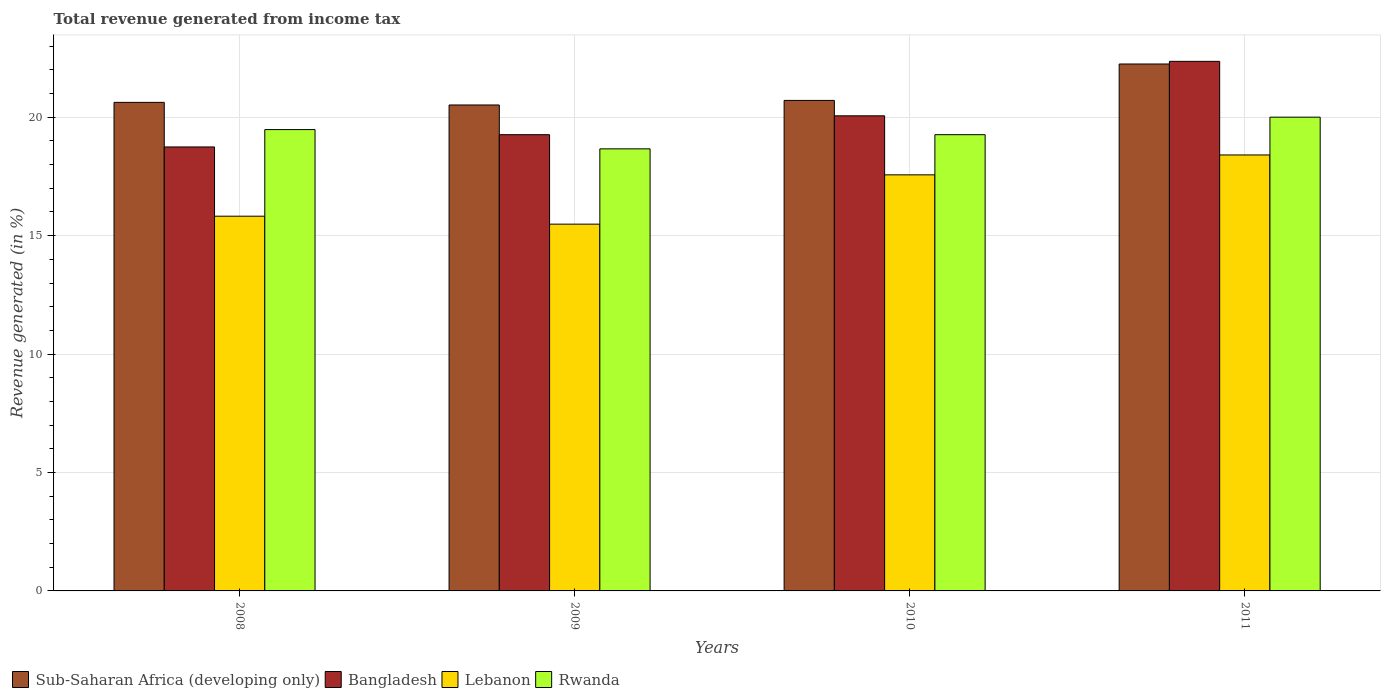How many different coloured bars are there?
Offer a terse response. 4. How many groups of bars are there?
Your answer should be very brief. 4. Are the number of bars per tick equal to the number of legend labels?
Make the answer very short. Yes. Are the number of bars on each tick of the X-axis equal?
Keep it short and to the point. Yes. What is the label of the 3rd group of bars from the left?
Provide a short and direct response. 2010. What is the total revenue generated in Lebanon in 2009?
Your response must be concise. 15.49. Across all years, what is the maximum total revenue generated in Rwanda?
Ensure brevity in your answer.  20. Across all years, what is the minimum total revenue generated in Bangladesh?
Give a very brief answer. 18.74. In which year was the total revenue generated in Rwanda maximum?
Keep it short and to the point. 2011. What is the total total revenue generated in Sub-Saharan Africa (developing only) in the graph?
Ensure brevity in your answer.  84.1. What is the difference between the total revenue generated in Rwanda in 2010 and that in 2011?
Your answer should be compact. -0.74. What is the difference between the total revenue generated in Bangladesh in 2008 and the total revenue generated in Sub-Saharan Africa (developing only) in 2009?
Keep it short and to the point. -1.77. What is the average total revenue generated in Rwanda per year?
Keep it short and to the point. 19.35. In the year 2008, what is the difference between the total revenue generated in Sub-Saharan Africa (developing only) and total revenue generated in Bangladesh?
Provide a succinct answer. 1.88. What is the ratio of the total revenue generated in Lebanon in 2009 to that in 2011?
Your answer should be compact. 0.84. Is the difference between the total revenue generated in Sub-Saharan Africa (developing only) in 2008 and 2009 greater than the difference between the total revenue generated in Bangladesh in 2008 and 2009?
Offer a terse response. Yes. What is the difference between the highest and the second highest total revenue generated in Rwanda?
Make the answer very short. 0.52. What is the difference between the highest and the lowest total revenue generated in Bangladesh?
Provide a succinct answer. 3.61. In how many years, is the total revenue generated in Bangladesh greater than the average total revenue generated in Bangladesh taken over all years?
Give a very brief answer. 1. Is the sum of the total revenue generated in Bangladesh in 2008 and 2011 greater than the maximum total revenue generated in Sub-Saharan Africa (developing only) across all years?
Provide a short and direct response. Yes. Is it the case that in every year, the sum of the total revenue generated in Rwanda and total revenue generated in Sub-Saharan Africa (developing only) is greater than the sum of total revenue generated in Bangladesh and total revenue generated in Lebanon?
Provide a succinct answer. Yes. What does the 1st bar from the left in 2010 represents?
Your answer should be very brief. Sub-Saharan Africa (developing only). What does the 4th bar from the right in 2008 represents?
Ensure brevity in your answer.  Sub-Saharan Africa (developing only). Is it the case that in every year, the sum of the total revenue generated in Bangladesh and total revenue generated in Lebanon is greater than the total revenue generated in Rwanda?
Provide a succinct answer. Yes. How many bars are there?
Your answer should be compact. 16. How many years are there in the graph?
Provide a short and direct response. 4. Where does the legend appear in the graph?
Make the answer very short. Bottom left. How are the legend labels stacked?
Provide a succinct answer. Horizontal. What is the title of the graph?
Your answer should be very brief. Total revenue generated from income tax. What is the label or title of the X-axis?
Offer a very short reply. Years. What is the label or title of the Y-axis?
Your response must be concise. Revenue generated (in %). What is the Revenue generated (in %) of Sub-Saharan Africa (developing only) in 2008?
Keep it short and to the point. 20.63. What is the Revenue generated (in %) in Bangladesh in 2008?
Your response must be concise. 18.74. What is the Revenue generated (in %) of Lebanon in 2008?
Provide a short and direct response. 15.82. What is the Revenue generated (in %) of Rwanda in 2008?
Provide a succinct answer. 19.48. What is the Revenue generated (in %) of Sub-Saharan Africa (developing only) in 2009?
Keep it short and to the point. 20.52. What is the Revenue generated (in %) in Bangladesh in 2009?
Your answer should be very brief. 19.26. What is the Revenue generated (in %) in Lebanon in 2009?
Keep it short and to the point. 15.49. What is the Revenue generated (in %) of Rwanda in 2009?
Provide a succinct answer. 18.66. What is the Revenue generated (in %) of Sub-Saharan Africa (developing only) in 2010?
Your response must be concise. 20.71. What is the Revenue generated (in %) of Bangladesh in 2010?
Your answer should be very brief. 20.06. What is the Revenue generated (in %) in Lebanon in 2010?
Give a very brief answer. 17.57. What is the Revenue generated (in %) in Rwanda in 2010?
Offer a very short reply. 19.26. What is the Revenue generated (in %) in Sub-Saharan Africa (developing only) in 2011?
Your answer should be compact. 22.25. What is the Revenue generated (in %) of Bangladesh in 2011?
Provide a short and direct response. 22.36. What is the Revenue generated (in %) in Lebanon in 2011?
Give a very brief answer. 18.41. What is the Revenue generated (in %) of Rwanda in 2011?
Your answer should be compact. 20. Across all years, what is the maximum Revenue generated (in %) in Sub-Saharan Africa (developing only)?
Your response must be concise. 22.25. Across all years, what is the maximum Revenue generated (in %) of Bangladesh?
Keep it short and to the point. 22.36. Across all years, what is the maximum Revenue generated (in %) in Lebanon?
Give a very brief answer. 18.41. Across all years, what is the maximum Revenue generated (in %) in Rwanda?
Make the answer very short. 20. Across all years, what is the minimum Revenue generated (in %) in Sub-Saharan Africa (developing only)?
Your answer should be compact. 20.52. Across all years, what is the minimum Revenue generated (in %) in Bangladesh?
Your answer should be compact. 18.74. Across all years, what is the minimum Revenue generated (in %) of Lebanon?
Your answer should be very brief. 15.49. Across all years, what is the minimum Revenue generated (in %) in Rwanda?
Ensure brevity in your answer.  18.66. What is the total Revenue generated (in %) of Sub-Saharan Africa (developing only) in the graph?
Keep it short and to the point. 84.1. What is the total Revenue generated (in %) in Bangladesh in the graph?
Offer a terse response. 80.42. What is the total Revenue generated (in %) in Lebanon in the graph?
Keep it short and to the point. 67.28. What is the total Revenue generated (in %) in Rwanda in the graph?
Keep it short and to the point. 77.41. What is the difference between the Revenue generated (in %) of Sub-Saharan Africa (developing only) in 2008 and that in 2009?
Your answer should be compact. 0.11. What is the difference between the Revenue generated (in %) of Bangladesh in 2008 and that in 2009?
Provide a succinct answer. -0.52. What is the difference between the Revenue generated (in %) in Lebanon in 2008 and that in 2009?
Your answer should be compact. 0.34. What is the difference between the Revenue generated (in %) in Rwanda in 2008 and that in 2009?
Your response must be concise. 0.81. What is the difference between the Revenue generated (in %) of Sub-Saharan Africa (developing only) in 2008 and that in 2010?
Ensure brevity in your answer.  -0.08. What is the difference between the Revenue generated (in %) of Bangladesh in 2008 and that in 2010?
Your response must be concise. -1.31. What is the difference between the Revenue generated (in %) in Lebanon in 2008 and that in 2010?
Provide a succinct answer. -1.75. What is the difference between the Revenue generated (in %) in Rwanda in 2008 and that in 2010?
Offer a terse response. 0.22. What is the difference between the Revenue generated (in %) in Sub-Saharan Africa (developing only) in 2008 and that in 2011?
Provide a short and direct response. -1.62. What is the difference between the Revenue generated (in %) of Bangladesh in 2008 and that in 2011?
Your response must be concise. -3.61. What is the difference between the Revenue generated (in %) of Lebanon in 2008 and that in 2011?
Provide a succinct answer. -2.59. What is the difference between the Revenue generated (in %) in Rwanda in 2008 and that in 2011?
Ensure brevity in your answer.  -0.52. What is the difference between the Revenue generated (in %) in Sub-Saharan Africa (developing only) in 2009 and that in 2010?
Keep it short and to the point. -0.19. What is the difference between the Revenue generated (in %) of Bangladesh in 2009 and that in 2010?
Your answer should be very brief. -0.8. What is the difference between the Revenue generated (in %) in Lebanon in 2009 and that in 2010?
Offer a very short reply. -2.08. What is the difference between the Revenue generated (in %) in Rwanda in 2009 and that in 2010?
Offer a terse response. -0.6. What is the difference between the Revenue generated (in %) in Sub-Saharan Africa (developing only) in 2009 and that in 2011?
Offer a terse response. -1.73. What is the difference between the Revenue generated (in %) in Bangladesh in 2009 and that in 2011?
Offer a terse response. -3.1. What is the difference between the Revenue generated (in %) in Lebanon in 2009 and that in 2011?
Provide a succinct answer. -2.92. What is the difference between the Revenue generated (in %) of Rwanda in 2009 and that in 2011?
Give a very brief answer. -1.34. What is the difference between the Revenue generated (in %) in Sub-Saharan Africa (developing only) in 2010 and that in 2011?
Provide a short and direct response. -1.54. What is the difference between the Revenue generated (in %) in Bangladesh in 2010 and that in 2011?
Offer a very short reply. -2.3. What is the difference between the Revenue generated (in %) in Lebanon in 2010 and that in 2011?
Give a very brief answer. -0.84. What is the difference between the Revenue generated (in %) in Rwanda in 2010 and that in 2011?
Keep it short and to the point. -0.74. What is the difference between the Revenue generated (in %) in Sub-Saharan Africa (developing only) in 2008 and the Revenue generated (in %) in Bangladesh in 2009?
Keep it short and to the point. 1.36. What is the difference between the Revenue generated (in %) of Sub-Saharan Africa (developing only) in 2008 and the Revenue generated (in %) of Lebanon in 2009?
Ensure brevity in your answer.  5.14. What is the difference between the Revenue generated (in %) of Sub-Saharan Africa (developing only) in 2008 and the Revenue generated (in %) of Rwanda in 2009?
Provide a succinct answer. 1.96. What is the difference between the Revenue generated (in %) of Bangladesh in 2008 and the Revenue generated (in %) of Lebanon in 2009?
Ensure brevity in your answer.  3.26. What is the difference between the Revenue generated (in %) of Bangladesh in 2008 and the Revenue generated (in %) of Rwanda in 2009?
Offer a very short reply. 0.08. What is the difference between the Revenue generated (in %) in Lebanon in 2008 and the Revenue generated (in %) in Rwanda in 2009?
Your answer should be very brief. -2.84. What is the difference between the Revenue generated (in %) of Sub-Saharan Africa (developing only) in 2008 and the Revenue generated (in %) of Bangladesh in 2010?
Keep it short and to the point. 0.57. What is the difference between the Revenue generated (in %) in Sub-Saharan Africa (developing only) in 2008 and the Revenue generated (in %) in Lebanon in 2010?
Your answer should be very brief. 3.06. What is the difference between the Revenue generated (in %) of Sub-Saharan Africa (developing only) in 2008 and the Revenue generated (in %) of Rwanda in 2010?
Make the answer very short. 1.36. What is the difference between the Revenue generated (in %) in Bangladesh in 2008 and the Revenue generated (in %) in Lebanon in 2010?
Keep it short and to the point. 1.18. What is the difference between the Revenue generated (in %) in Bangladesh in 2008 and the Revenue generated (in %) in Rwanda in 2010?
Your answer should be compact. -0.52. What is the difference between the Revenue generated (in %) in Lebanon in 2008 and the Revenue generated (in %) in Rwanda in 2010?
Keep it short and to the point. -3.44. What is the difference between the Revenue generated (in %) in Sub-Saharan Africa (developing only) in 2008 and the Revenue generated (in %) in Bangladesh in 2011?
Provide a short and direct response. -1.73. What is the difference between the Revenue generated (in %) of Sub-Saharan Africa (developing only) in 2008 and the Revenue generated (in %) of Lebanon in 2011?
Keep it short and to the point. 2.22. What is the difference between the Revenue generated (in %) of Sub-Saharan Africa (developing only) in 2008 and the Revenue generated (in %) of Rwanda in 2011?
Provide a succinct answer. 0.62. What is the difference between the Revenue generated (in %) of Bangladesh in 2008 and the Revenue generated (in %) of Lebanon in 2011?
Your response must be concise. 0.34. What is the difference between the Revenue generated (in %) of Bangladesh in 2008 and the Revenue generated (in %) of Rwanda in 2011?
Your answer should be compact. -1.26. What is the difference between the Revenue generated (in %) of Lebanon in 2008 and the Revenue generated (in %) of Rwanda in 2011?
Offer a very short reply. -4.18. What is the difference between the Revenue generated (in %) in Sub-Saharan Africa (developing only) in 2009 and the Revenue generated (in %) in Bangladesh in 2010?
Your answer should be compact. 0.46. What is the difference between the Revenue generated (in %) of Sub-Saharan Africa (developing only) in 2009 and the Revenue generated (in %) of Lebanon in 2010?
Make the answer very short. 2.95. What is the difference between the Revenue generated (in %) in Sub-Saharan Africa (developing only) in 2009 and the Revenue generated (in %) in Rwanda in 2010?
Offer a terse response. 1.25. What is the difference between the Revenue generated (in %) of Bangladesh in 2009 and the Revenue generated (in %) of Lebanon in 2010?
Make the answer very short. 1.7. What is the difference between the Revenue generated (in %) in Bangladesh in 2009 and the Revenue generated (in %) in Rwanda in 2010?
Keep it short and to the point. 0. What is the difference between the Revenue generated (in %) in Lebanon in 2009 and the Revenue generated (in %) in Rwanda in 2010?
Your answer should be compact. -3.78. What is the difference between the Revenue generated (in %) of Sub-Saharan Africa (developing only) in 2009 and the Revenue generated (in %) of Bangladesh in 2011?
Keep it short and to the point. -1.84. What is the difference between the Revenue generated (in %) in Sub-Saharan Africa (developing only) in 2009 and the Revenue generated (in %) in Lebanon in 2011?
Your answer should be compact. 2.11. What is the difference between the Revenue generated (in %) in Sub-Saharan Africa (developing only) in 2009 and the Revenue generated (in %) in Rwanda in 2011?
Make the answer very short. 0.51. What is the difference between the Revenue generated (in %) of Bangladesh in 2009 and the Revenue generated (in %) of Lebanon in 2011?
Make the answer very short. 0.86. What is the difference between the Revenue generated (in %) of Bangladesh in 2009 and the Revenue generated (in %) of Rwanda in 2011?
Offer a very short reply. -0.74. What is the difference between the Revenue generated (in %) of Lebanon in 2009 and the Revenue generated (in %) of Rwanda in 2011?
Provide a short and direct response. -4.52. What is the difference between the Revenue generated (in %) in Sub-Saharan Africa (developing only) in 2010 and the Revenue generated (in %) in Bangladesh in 2011?
Your answer should be very brief. -1.65. What is the difference between the Revenue generated (in %) in Sub-Saharan Africa (developing only) in 2010 and the Revenue generated (in %) in Lebanon in 2011?
Offer a very short reply. 2.3. What is the difference between the Revenue generated (in %) in Sub-Saharan Africa (developing only) in 2010 and the Revenue generated (in %) in Rwanda in 2011?
Your answer should be compact. 0.71. What is the difference between the Revenue generated (in %) in Bangladesh in 2010 and the Revenue generated (in %) in Lebanon in 2011?
Your answer should be compact. 1.65. What is the difference between the Revenue generated (in %) of Bangladesh in 2010 and the Revenue generated (in %) of Rwanda in 2011?
Keep it short and to the point. 0.06. What is the difference between the Revenue generated (in %) of Lebanon in 2010 and the Revenue generated (in %) of Rwanda in 2011?
Provide a succinct answer. -2.44. What is the average Revenue generated (in %) of Sub-Saharan Africa (developing only) per year?
Your answer should be compact. 21.02. What is the average Revenue generated (in %) in Bangladesh per year?
Offer a very short reply. 20.11. What is the average Revenue generated (in %) of Lebanon per year?
Offer a very short reply. 16.82. What is the average Revenue generated (in %) of Rwanda per year?
Keep it short and to the point. 19.35. In the year 2008, what is the difference between the Revenue generated (in %) of Sub-Saharan Africa (developing only) and Revenue generated (in %) of Bangladesh?
Your answer should be very brief. 1.88. In the year 2008, what is the difference between the Revenue generated (in %) of Sub-Saharan Africa (developing only) and Revenue generated (in %) of Lebanon?
Ensure brevity in your answer.  4.81. In the year 2008, what is the difference between the Revenue generated (in %) in Sub-Saharan Africa (developing only) and Revenue generated (in %) in Rwanda?
Offer a very short reply. 1.15. In the year 2008, what is the difference between the Revenue generated (in %) in Bangladesh and Revenue generated (in %) in Lebanon?
Your answer should be compact. 2.92. In the year 2008, what is the difference between the Revenue generated (in %) of Bangladesh and Revenue generated (in %) of Rwanda?
Ensure brevity in your answer.  -0.73. In the year 2008, what is the difference between the Revenue generated (in %) in Lebanon and Revenue generated (in %) in Rwanda?
Your answer should be very brief. -3.66. In the year 2009, what is the difference between the Revenue generated (in %) in Sub-Saharan Africa (developing only) and Revenue generated (in %) in Bangladesh?
Provide a succinct answer. 1.25. In the year 2009, what is the difference between the Revenue generated (in %) in Sub-Saharan Africa (developing only) and Revenue generated (in %) in Lebanon?
Ensure brevity in your answer.  5.03. In the year 2009, what is the difference between the Revenue generated (in %) in Sub-Saharan Africa (developing only) and Revenue generated (in %) in Rwanda?
Offer a terse response. 1.85. In the year 2009, what is the difference between the Revenue generated (in %) in Bangladesh and Revenue generated (in %) in Lebanon?
Your answer should be very brief. 3.78. In the year 2009, what is the difference between the Revenue generated (in %) in Bangladesh and Revenue generated (in %) in Rwanda?
Offer a very short reply. 0.6. In the year 2009, what is the difference between the Revenue generated (in %) in Lebanon and Revenue generated (in %) in Rwanda?
Your answer should be compact. -3.18. In the year 2010, what is the difference between the Revenue generated (in %) of Sub-Saharan Africa (developing only) and Revenue generated (in %) of Bangladesh?
Ensure brevity in your answer.  0.65. In the year 2010, what is the difference between the Revenue generated (in %) of Sub-Saharan Africa (developing only) and Revenue generated (in %) of Lebanon?
Your answer should be very brief. 3.14. In the year 2010, what is the difference between the Revenue generated (in %) of Sub-Saharan Africa (developing only) and Revenue generated (in %) of Rwanda?
Ensure brevity in your answer.  1.45. In the year 2010, what is the difference between the Revenue generated (in %) in Bangladesh and Revenue generated (in %) in Lebanon?
Your answer should be compact. 2.49. In the year 2010, what is the difference between the Revenue generated (in %) of Bangladesh and Revenue generated (in %) of Rwanda?
Provide a short and direct response. 0.8. In the year 2010, what is the difference between the Revenue generated (in %) of Lebanon and Revenue generated (in %) of Rwanda?
Offer a terse response. -1.7. In the year 2011, what is the difference between the Revenue generated (in %) of Sub-Saharan Africa (developing only) and Revenue generated (in %) of Bangladesh?
Keep it short and to the point. -0.11. In the year 2011, what is the difference between the Revenue generated (in %) of Sub-Saharan Africa (developing only) and Revenue generated (in %) of Lebanon?
Provide a succinct answer. 3.84. In the year 2011, what is the difference between the Revenue generated (in %) in Sub-Saharan Africa (developing only) and Revenue generated (in %) in Rwanda?
Give a very brief answer. 2.24. In the year 2011, what is the difference between the Revenue generated (in %) in Bangladesh and Revenue generated (in %) in Lebanon?
Offer a very short reply. 3.95. In the year 2011, what is the difference between the Revenue generated (in %) of Bangladesh and Revenue generated (in %) of Rwanda?
Your answer should be very brief. 2.36. In the year 2011, what is the difference between the Revenue generated (in %) of Lebanon and Revenue generated (in %) of Rwanda?
Your answer should be very brief. -1.6. What is the ratio of the Revenue generated (in %) in Sub-Saharan Africa (developing only) in 2008 to that in 2009?
Provide a succinct answer. 1.01. What is the ratio of the Revenue generated (in %) in Bangladesh in 2008 to that in 2009?
Make the answer very short. 0.97. What is the ratio of the Revenue generated (in %) in Lebanon in 2008 to that in 2009?
Your answer should be very brief. 1.02. What is the ratio of the Revenue generated (in %) in Rwanda in 2008 to that in 2009?
Your answer should be compact. 1.04. What is the ratio of the Revenue generated (in %) of Sub-Saharan Africa (developing only) in 2008 to that in 2010?
Provide a short and direct response. 1. What is the ratio of the Revenue generated (in %) of Bangladesh in 2008 to that in 2010?
Your response must be concise. 0.93. What is the ratio of the Revenue generated (in %) of Lebanon in 2008 to that in 2010?
Offer a terse response. 0.9. What is the ratio of the Revenue generated (in %) in Rwanda in 2008 to that in 2010?
Your response must be concise. 1.01. What is the ratio of the Revenue generated (in %) of Sub-Saharan Africa (developing only) in 2008 to that in 2011?
Give a very brief answer. 0.93. What is the ratio of the Revenue generated (in %) in Bangladesh in 2008 to that in 2011?
Provide a succinct answer. 0.84. What is the ratio of the Revenue generated (in %) in Lebanon in 2008 to that in 2011?
Offer a very short reply. 0.86. What is the ratio of the Revenue generated (in %) of Rwanda in 2008 to that in 2011?
Provide a short and direct response. 0.97. What is the ratio of the Revenue generated (in %) in Bangladesh in 2009 to that in 2010?
Provide a short and direct response. 0.96. What is the ratio of the Revenue generated (in %) of Lebanon in 2009 to that in 2010?
Offer a very short reply. 0.88. What is the ratio of the Revenue generated (in %) of Rwanda in 2009 to that in 2010?
Make the answer very short. 0.97. What is the ratio of the Revenue generated (in %) in Sub-Saharan Africa (developing only) in 2009 to that in 2011?
Give a very brief answer. 0.92. What is the ratio of the Revenue generated (in %) in Bangladesh in 2009 to that in 2011?
Provide a short and direct response. 0.86. What is the ratio of the Revenue generated (in %) in Lebanon in 2009 to that in 2011?
Make the answer very short. 0.84. What is the ratio of the Revenue generated (in %) in Rwanda in 2009 to that in 2011?
Keep it short and to the point. 0.93. What is the ratio of the Revenue generated (in %) of Sub-Saharan Africa (developing only) in 2010 to that in 2011?
Provide a short and direct response. 0.93. What is the ratio of the Revenue generated (in %) in Bangladesh in 2010 to that in 2011?
Provide a short and direct response. 0.9. What is the ratio of the Revenue generated (in %) of Lebanon in 2010 to that in 2011?
Ensure brevity in your answer.  0.95. What is the difference between the highest and the second highest Revenue generated (in %) of Sub-Saharan Africa (developing only)?
Provide a short and direct response. 1.54. What is the difference between the highest and the second highest Revenue generated (in %) in Bangladesh?
Make the answer very short. 2.3. What is the difference between the highest and the second highest Revenue generated (in %) in Lebanon?
Keep it short and to the point. 0.84. What is the difference between the highest and the second highest Revenue generated (in %) in Rwanda?
Offer a very short reply. 0.52. What is the difference between the highest and the lowest Revenue generated (in %) in Sub-Saharan Africa (developing only)?
Ensure brevity in your answer.  1.73. What is the difference between the highest and the lowest Revenue generated (in %) in Bangladesh?
Offer a very short reply. 3.61. What is the difference between the highest and the lowest Revenue generated (in %) of Lebanon?
Provide a short and direct response. 2.92. What is the difference between the highest and the lowest Revenue generated (in %) of Rwanda?
Your response must be concise. 1.34. 